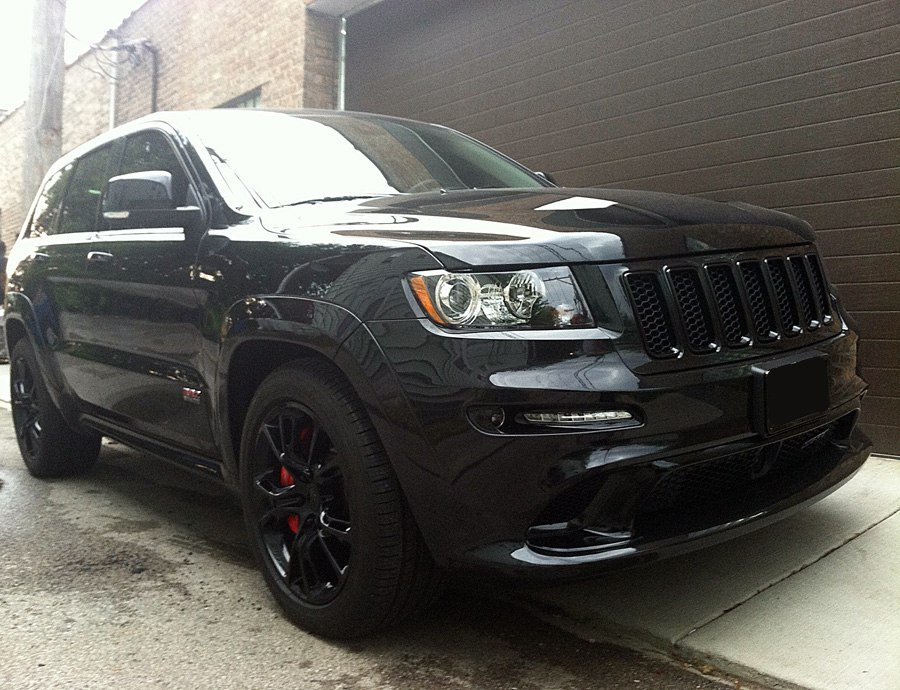How does the paint finish of this SUV contribute to its overall aesthetic and perception by observers? The glossy black paint finish on this SUV significantly enhances its sleek and aggressive appearance, contributing to a modern and sophisticated aesthetic. This finish reflects light in a way that accentuates the SUV's curves and lines, giving it a sense of dynamism and elegance. Observers may perceive the vehicle as not only a powerful machine but also as a statement of style and luxury, suggesting a discerning taste and appreciation for high-quality design. 